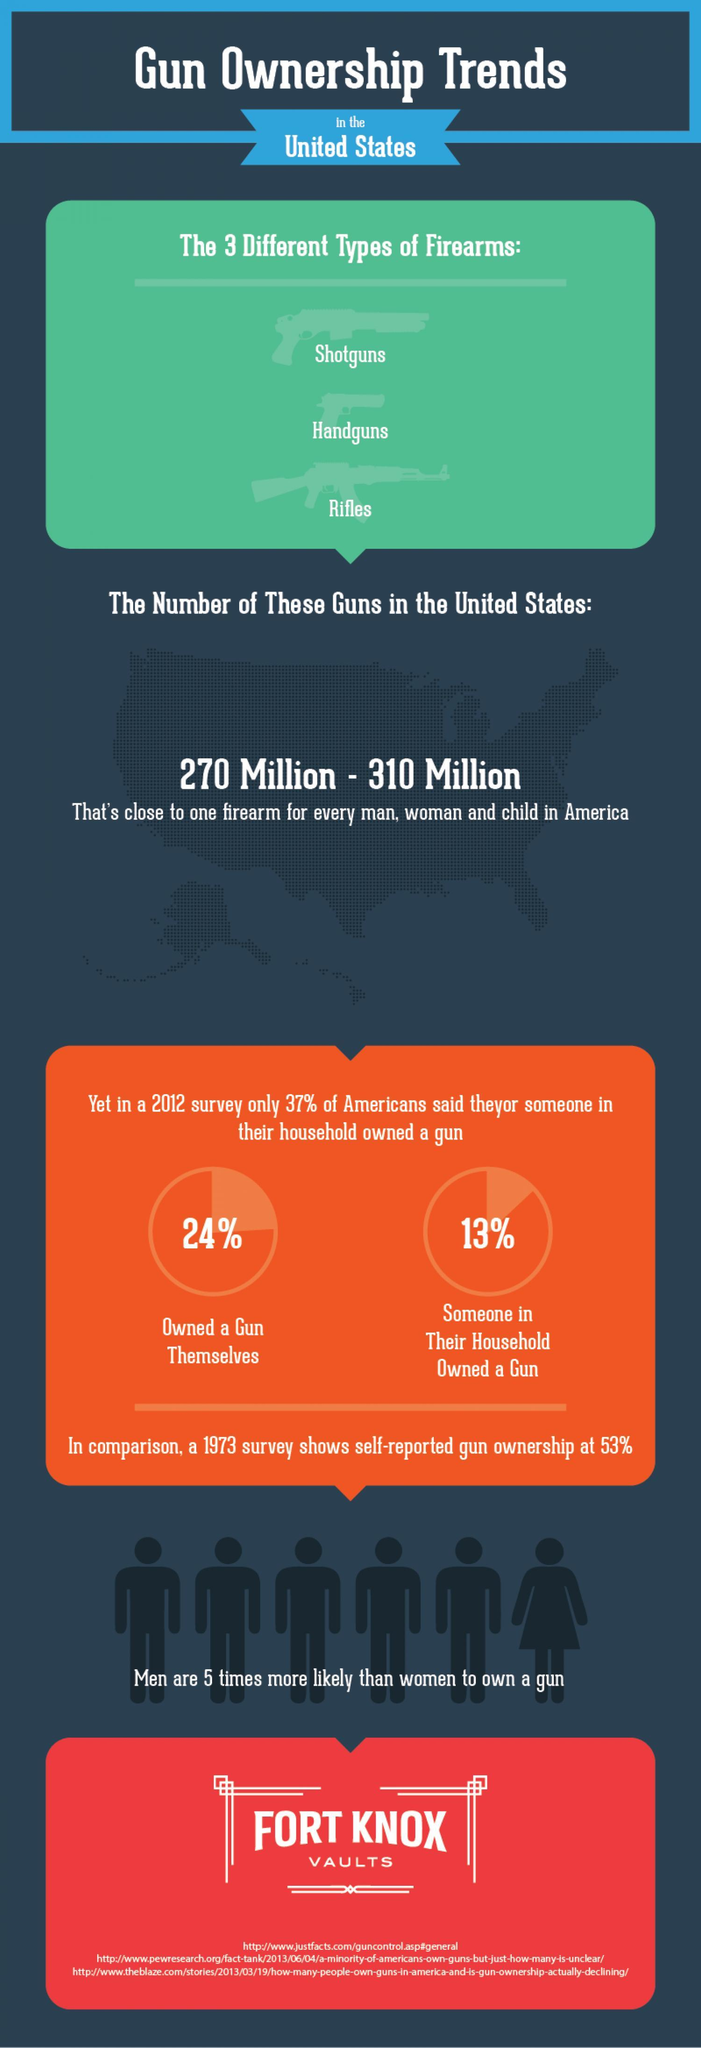What is the total number of guns owned by the Americans?
Answer the question with a short phrase. 270 Million - 310 Million What percent of Americans do not own a gun themselves in 2012 survey? 76% Which gender is more likely to own a gun in the U.S.? Men What are the three types of guns widely used in U.S? Shotguns, Handguns, Rifles 